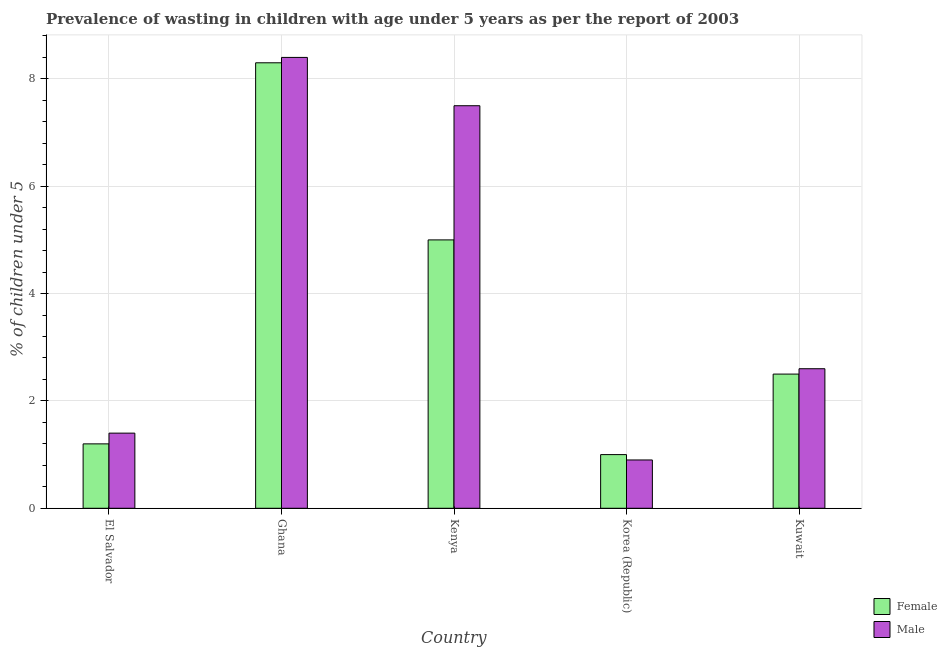How many different coloured bars are there?
Give a very brief answer. 2. Are the number of bars per tick equal to the number of legend labels?
Provide a short and direct response. Yes. Are the number of bars on each tick of the X-axis equal?
Your answer should be compact. Yes. How many bars are there on the 2nd tick from the right?
Keep it short and to the point. 2. What is the label of the 2nd group of bars from the left?
Your response must be concise. Ghana. What is the percentage of undernourished male children in Kuwait?
Your response must be concise. 2.6. Across all countries, what is the maximum percentage of undernourished male children?
Provide a short and direct response. 8.4. Across all countries, what is the minimum percentage of undernourished male children?
Your response must be concise. 0.9. What is the total percentage of undernourished male children in the graph?
Keep it short and to the point. 20.8. What is the difference between the percentage of undernourished male children in Korea (Republic) and that in Kuwait?
Make the answer very short. -1.7. What is the difference between the percentage of undernourished female children in Kenya and the percentage of undernourished male children in Ghana?
Your answer should be compact. -3.4. What is the average percentage of undernourished male children per country?
Your answer should be compact. 4.16. What is the difference between the percentage of undernourished male children and percentage of undernourished female children in Kenya?
Your response must be concise. 2.5. In how many countries, is the percentage of undernourished female children greater than 2 %?
Offer a terse response. 3. What is the ratio of the percentage of undernourished female children in Kenya to that in Korea (Republic)?
Offer a terse response. 5. What is the difference between the highest and the second highest percentage of undernourished male children?
Give a very brief answer. 0.9. What is the difference between the highest and the lowest percentage of undernourished male children?
Your answer should be compact. 7.5. In how many countries, is the percentage of undernourished female children greater than the average percentage of undernourished female children taken over all countries?
Keep it short and to the point. 2. Is the sum of the percentage of undernourished male children in Kenya and Kuwait greater than the maximum percentage of undernourished female children across all countries?
Ensure brevity in your answer.  Yes. Are all the bars in the graph horizontal?
Your answer should be compact. No. What is the difference between two consecutive major ticks on the Y-axis?
Your answer should be compact. 2. Are the values on the major ticks of Y-axis written in scientific E-notation?
Offer a terse response. No. Does the graph contain any zero values?
Ensure brevity in your answer.  No. Where does the legend appear in the graph?
Keep it short and to the point. Bottom right. How many legend labels are there?
Keep it short and to the point. 2. How are the legend labels stacked?
Ensure brevity in your answer.  Vertical. What is the title of the graph?
Your answer should be compact. Prevalence of wasting in children with age under 5 years as per the report of 2003. What is the label or title of the X-axis?
Offer a terse response. Country. What is the label or title of the Y-axis?
Your answer should be compact.  % of children under 5. What is the  % of children under 5 of Female in El Salvador?
Make the answer very short. 1.2. What is the  % of children under 5 of Male in El Salvador?
Your answer should be very brief. 1.4. What is the  % of children under 5 in Female in Ghana?
Your response must be concise. 8.3. What is the  % of children under 5 of Male in Ghana?
Keep it short and to the point. 8.4. What is the  % of children under 5 in Male in Korea (Republic)?
Offer a terse response. 0.9. What is the  % of children under 5 in Male in Kuwait?
Ensure brevity in your answer.  2.6. Across all countries, what is the maximum  % of children under 5 in Female?
Ensure brevity in your answer.  8.3. Across all countries, what is the maximum  % of children under 5 in Male?
Offer a very short reply. 8.4. Across all countries, what is the minimum  % of children under 5 of Male?
Keep it short and to the point. 0.9. What is the total  % of children under 5 in Female in the graph?
Offer a terse response. 18. What is the total  % of children under 5 in Male in the graph?
Provide a short and direct response. 20.8. What is the difference between the  % of children under 5 in Female in El Salvador and that in Ghana?
Offer a terse response. -7.1. What is the difference between the  % of children under 5 in Female in El Salvador and that in Kenya?
Ensure brevity in your answer.  -3.8. What is the difference between the  % of children under 5 in Male in El Salvador and that in Kuwait?
Make the answer very short. -1.2. What is the difference between the  % of children under 5 of Female in Ghana and that in Kenya?
Offer a very short reply. 3.3. What is the difference between the  % of children under 5 of Female in Ghana and that in Korea (Republic)?
Ensure brevity in your answer.  7.3. What is the difference between the  % of children under 5 in Female in Kenya and that in Korea (Republic)?
Offer a terse response. 4. What is the difference between the  % of children under 5 of Male in Kenya and that in Korea (Republic)?
Offer a terse response. 6.6. What is the difference between the  % of children under 5 in Male in Kenya and that in Kuwait?
Provide a short and direct response. 4.9. What is the difference between the  % of children under 5 in Male in Korea (Republic) and that in Kuwait?
Your answer should be very brief. -1.7. What is the difference between the  % of children under 5 in Female in El Salvador and the  % of children under 5 in Male in Ghana?
Your answer should be compact. -7.2. What is the difference between the  % of children under 5 in Female in El Salvador and the  % of children under 5 in Male in Kenya?
Keep it short and to the point. -6.3. What is the difference between the  % of children under 5 in Female in El Salvador and the  % of children under 5 in Male in Kuwait?
Provide a succinct answer. -1.4. What is the difference between the  % of children under 5 in Female in Ghana and the  % of children under 5 in Male in Kenya?
Offer a terse response. 0.8. What is the difference between the  % of children under 5 in Female in Ghana and the  % of children under 5 in Male in Korea (Republic)?
Your response must be concise. 7.4. What is the difference between the  % of children under 5 in Female in Korea (Republic) and the  % of children under 5 in Male in Kuwait?
Your response must be concise. -1.6. What is the average  % of children under 5 in Female per country?
Provide a succinct answer. 3.6. What is the average  % of children under 5 of Male per country?
Make the answer very short. 4.16. What is the difference between the  % of children under 5 of Female and  % of children under 5 of Male in Ghana?
Your answer should be compact. -0.1. What is the difference between the  % of children under 5 in Female and  % of children under 5 in Male in Kenya?
Provide a succinct answer. -2.5. What is the ratio of the  % of children under 5 in Female in El Salvador to that in Ghana?
Keep it short and to the point. 0.14. What is the ratio of the  % of children under 5 in Female in El Salvador to that in Kenya?
Keep it short and to the point. 0.24. What is the ratio of the  % of children under 5 of Male in El Salvador to that in Kenya?
Offer a terse response. 0.19. What is the ratio of the  % of children under 5 in Male in El Salvador to that in Korea (Republic)?
Your answer should be very brief. 1.56. What is the ratio of the  % of children under 5 in Female in El Salvador to that in Kuwait?
Give a very brief answer. 0.48. What is the ratio of the  % of children under 5 in Male in El Salvador to that in Kuwait?
Your answer should be compact. 0.54. What is the ratio of the  % of children under 5 in Female in Ghana to that in Kenya?
Offer a terse response. 1.66. What is the ratio of the  % of children under 5 of Male in Ghana to that in Kenya?
Give a very brief answer. 1.12. What is the ratio of the  % of children under 5 of Male in Ghana to that in Korea (Republic)?
Keep it short and to the point. 9.33. What is the ratio of the  % of children under 5 in Female in Ghana to that in Kuwait?
Your answer should be compact. 3.32. What is the ratio of the  % of children under 5 in Male in Ghana to that in Kuwait?
Give a very brief answer. 3.23. What is the ratio of the  % of children under 5 in Female in Kenya to that in Korea (Republic)?
Provide a succinct answer. 5. What is the ratio of the  % of children under 5 of Male in Kenya to that in Korea (Republic)?
Keep it short and to the point. 8.33. What is the ratio of the  % of children under 5 in Female in Kenya to that in Kuwait?
Provide a succinct answer. 2. What is the ratio of the  % of children under 5 of Male in Kenya to that in Kuwait?
Give a very brief answer. 2.88. What is the ratio of the  % of children under 5 in Female in Korea (Republic) to that in Kuwait?
Give a very brief answer. 0.4. What is the ratio of the  % of children under 5 in Male in Korea (Republic) to that in Kuwait?
Provide a succinct answer. 0.35. What is the difference between the highest and the second highest  % of children under 5 in Male?
Provide a short and direct response. 0.9. What is the difference between the highest and the lowest  % of children under 5 of Female?
Give a very brief answer. 7.3. What is the difference between the highest and the lowest  % of children under 5 of Male?
Ensure brevity in your answer.  7.5. 